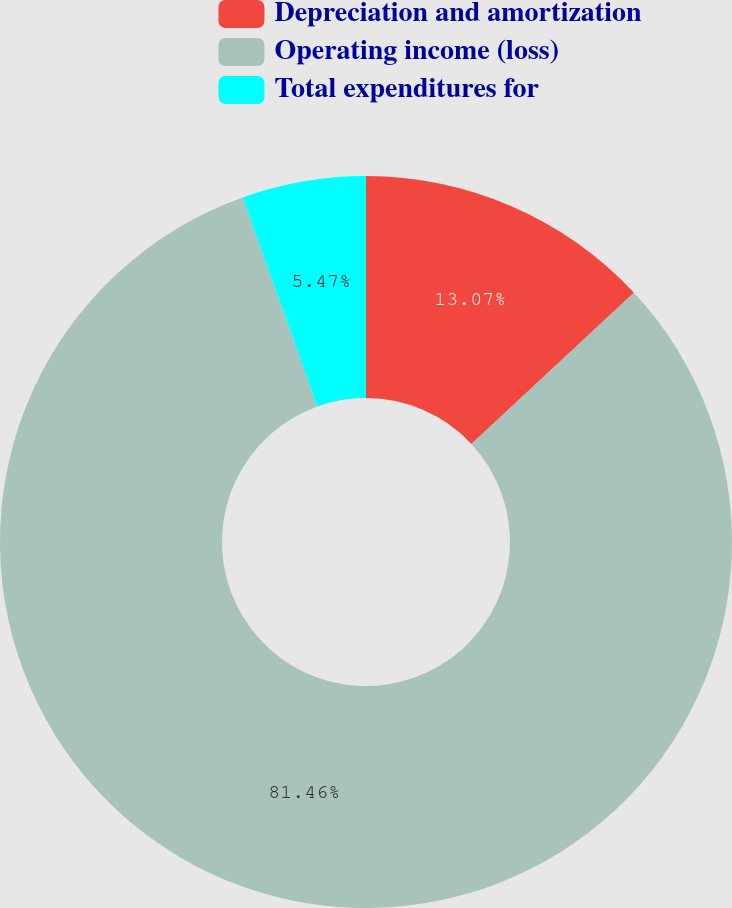Convert chart. <chart><loc_0><loc_0><loc_500><loc_500><pie_chart><fcel>Depreciation and amortization<fcel>Operating income (loss)<fcel>Total expenditures for<nl><fcel>13.07%<fcel>81.45%<fcel>5.47%<nl></chart> 